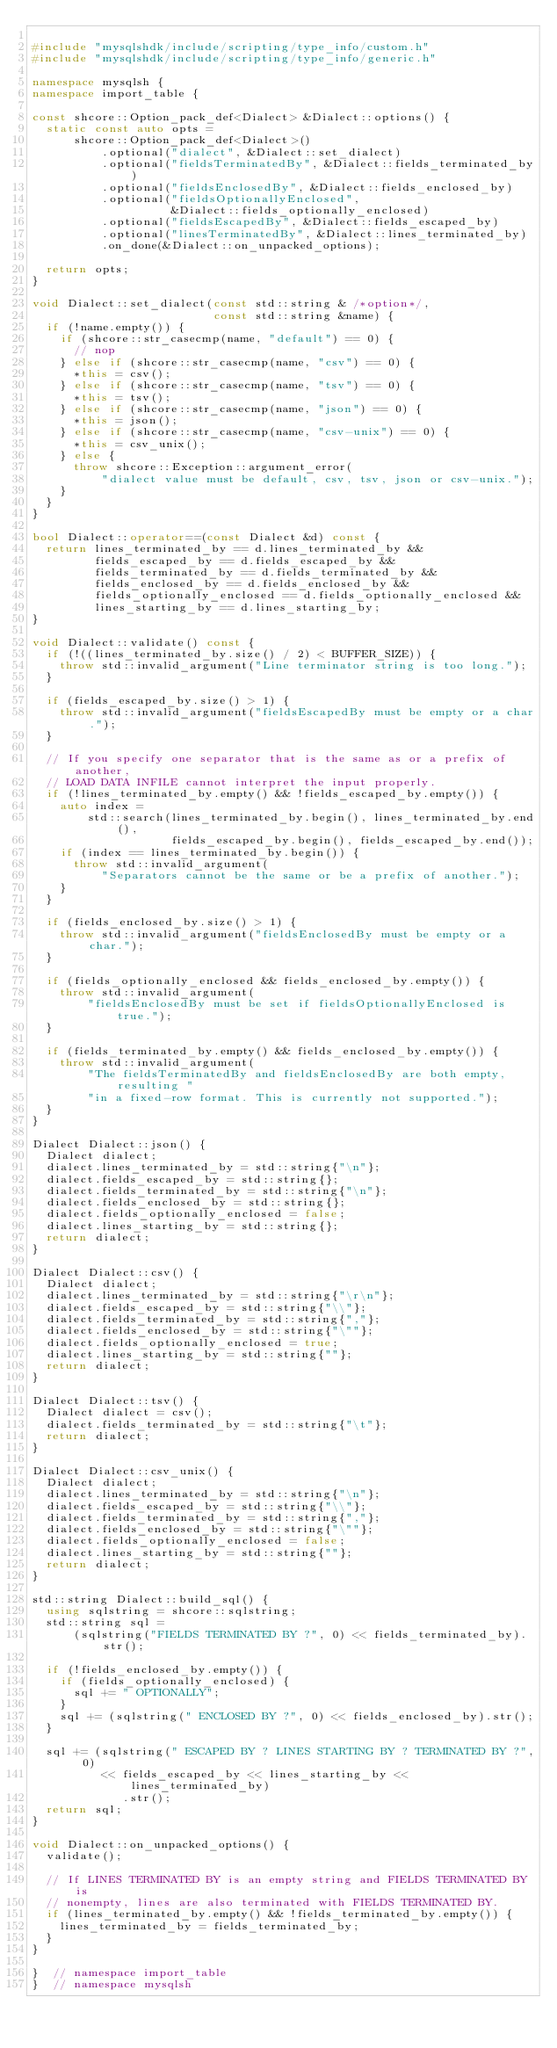<code> <loc_0><loc_0><loc_500><loc_500><_C++_>
#include "mysqlshdk/include/scripting/type_info/custom.h"
#include "mysqlshdk/include/scripting/type_info/generic.h"

namespace mysqlsh {
namespace import_table {

const shcore::Option_pack_def<Dialect> &Dialect::options() {
  static const auto opts =
      shcore::Option_pack_def<Dialect>()
          .optional("dialect", &Dialect::set_dialect)
          .optional("fieldsTerminatedBy", &Dialect::fields_terminated_by)
          .optional("fieldsEnclosedBy", &Dialect::fields_enclosed_by)
          .optional("fieldsOptionallyEnclosed",
                    &Dialect::fields_optionally_enclosed)
          .optional("fieldsEscapedBy", &Dialect::fields_escaped_by)
          .optional("linesTerminatedBy", &Dialect::lines_terminated_by)
          .on_done(&Dialect::on_unpacked_options);

  return opts;
}

void Dialect::set_dialect(const std::string & /*option*/,
                          const std::string &name) {
  if (!name.empty()) {
    if (shcore::str_casecmp(name, "default") == 0) {
      // nop
    } else if (shcore::str_casecmp(name, "csv") == 0) {
      *this = csv();
    } else if (shcore::str_casecmp(name, "tsv") == 0) {
      *this = tsv();
    } else if (shcore::str_casecmp(name, "json") == 0) {
      *this = json();
    } else if (shcore::str_casecmp(name, "csv-unix") == 0) {
      *this = csv_unix();
    } else {
      throw shcore::Exception::argument_error(
          "dialect value must be default, csv, tsv, json or csv-unix.");
    }
  }
}

bool Dialect::operator==(const Dialect &d) const {
  return lines_terminated_by == d.lines_terminated_by &&
         fields_escaped_by == d.fields_escaped_by &&
         fields_terminated_by == d.fields_terminated_by &&
         fields_enclosed_by == d.fields_enclosed_by &&
         fields_optionally_enclosed == d.fields_optionally_enclosed &&
         lines_starting_by == d.lines_starting_by;
}

void Dialect::validate() const {
  if (!((lines_terminated_by.size() / 2) < BUFFER_SIZE)) {
    throw std::invalid_argument("Line terminator string is too long.");
  }

  if (fields_escaped_by.size() > 1) {
    throw std::invalid_argument("fieldsEscapedBy must be empty or a char.");
  }

  // If you specify one separator that is the same as or a prefix of another,
  // LOAD DATA INFILE cannot interpret the input properly.
  if (!lines_terminated_by.empty() && !fields_escaped_by.empty()) {
    auto index =
        std::search(lines_terminated_by.begin(), lines_terminated_by.end(),
                    fields_escaped_by.begin(), fields_escaped_by.end());
    if (index == lines_terminated_by.begin()) {
      throw std::invalid_argument(
          "Separators cannot be the same or be a prefix of another.");
    }
  }

  if (fields_enclosed_by.size() > 1) {
    throw std::invalid_argument("fieldsEnclosedBy must be empty or a char.");
  }

  if (fields_optionally_enclosed && fields_enclosed_by.empty()) {
    throw std::invalid_argument(
        "fieldsEnclosedBy must be set if fieldsOptionallyEnclosed is true.");
  }

  if (fields_terminated_by.empty() && fields_enclosed_by.empty()) {
    throw std::invalid_argument(
        "The fieldsTerminatedBy and fieldsEnclosedBy are both empty, resulting "
        "in a fixed-row format. This is currently not supported.");
  }
}

Dialect Dialect::json() {
  Dialect dialect;
  dialect.lines_terminated_by = std::string{"\n"};
  dialect.fields_escaped_by = std::string{};
  dialect.fields_terminated_by = std::string{"\n"};
  dialect.fields_enclosed_by = std::string{};
  dialect.fields_optionally_enclosed = false;
  dialect.lines_starting_by = std::string{};
  return dialect;
}

Dialect Dialect::csv() {
  Dialect dialect;
  dialect.lines_terminated_by = std::string{"\r\n"};
  dialect.fields_escaped_by = std::string{"\\"};
  dialect.fields_terminated_by = std::string{","};
  dialect.fields_enclosed_by = std::string{"\""};
  dialect.fields_optionally_enclosed = true;
  dialect.lines_starting_by = std::string{""};
  return dialect;
}

Dialect Dialect::tsv() {
  Dialect dialect = csv();
  dialect.fields_terminated_by = std::string{"\t"};
  return dialect;
}

Dialect Dialect::csv_unix() {
  Dialect dialect;
  dialect.lines_terminated_by = std::string{"\n"};
  dialect.fields_escaped_by = std::string{"\\"};
  dialect.fields_terminated_by = std::string{","};
  dialect.fields_enclosed_by = std::string{"\""};
  dialect.fields_optionally_enclosed = false;
  dialect.lines_starting_by = std::string{""};
  return dialect;
}

std::string Dialect::build_sql() {
  using sqlstring = shcore::sqlstring;
  std::string sql =
      (sqlstring("FIELDS TERMINATED BY ?", 0) << fields_terminated_by).str();

  if (!fields_enclosed_by.empty()) {
    if (fields_optionally_enclosed) {
      sql += " OPTIONALLY";
    }
    sql += (sqlstring(" ENCLOSED BY ?", 0) << fields_enclosed_by).str();
  }

  sql += (sqlstring(" ESCAPED BY ? LINES STARTING BY ? TERMINATED BY ?", 0)
          << fields_escaped_by << lines_starting_by << lines_terminated_by)
             .str();
  return sql;
}

void Dialect::on_unpacked_options() {
  validate();

  // If LINES TERMINATED BY is an empty string and FIELDS TERMINATED BY is
  // nonempty, lines are also terminated with FIELDS TERMINATED BY.
  if (lines_terminated_by.empty() && !fields_terminated_by.empty()) {
    lines_terminated_by = fields_terminated_by;
  }
}

}  // namespace import_table
}  // namespace mysqlsh
</code> 